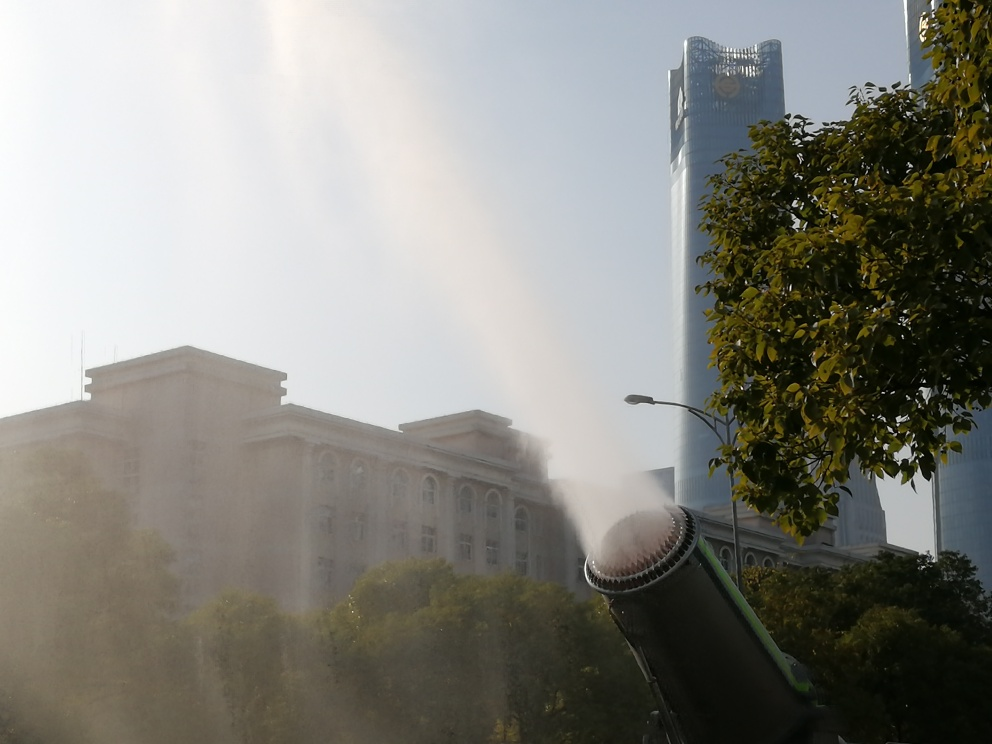Are there any quality issues with this image? The image is slightly overexposed, which affects the visibility of detail in the brighter areas. Additionally, there is a significant amount of mist or haze, likely from the water cannon, which creates a veil effect over the buildings and reduces contrast and sharpness across the photo. 